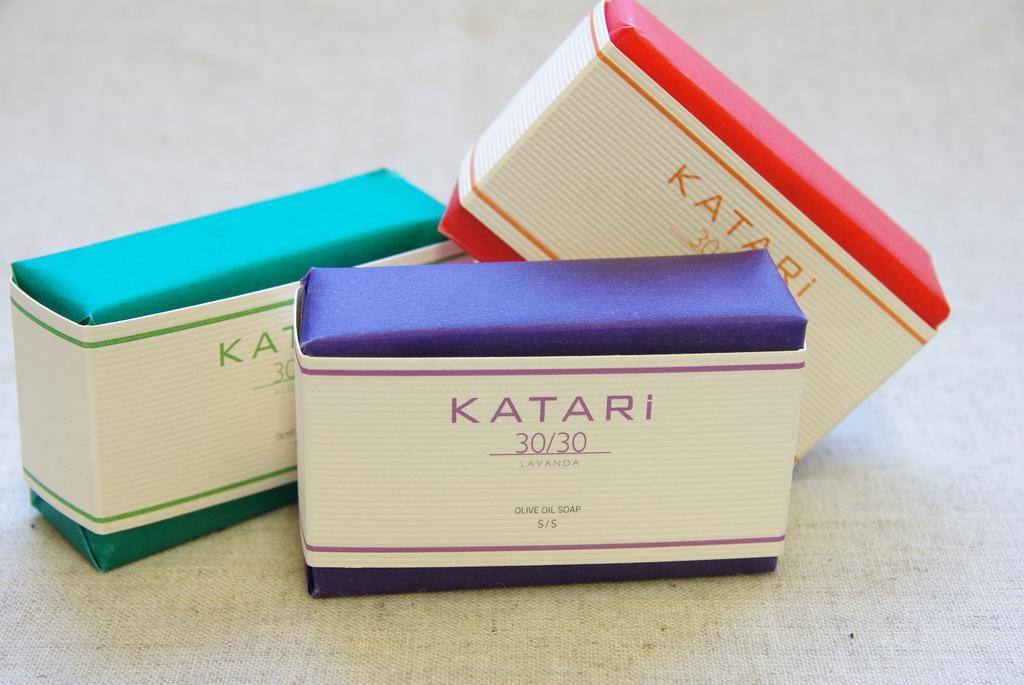<image>
Create a compact narrative representing the image presented. Three different bars of Katari olive oil soap. 